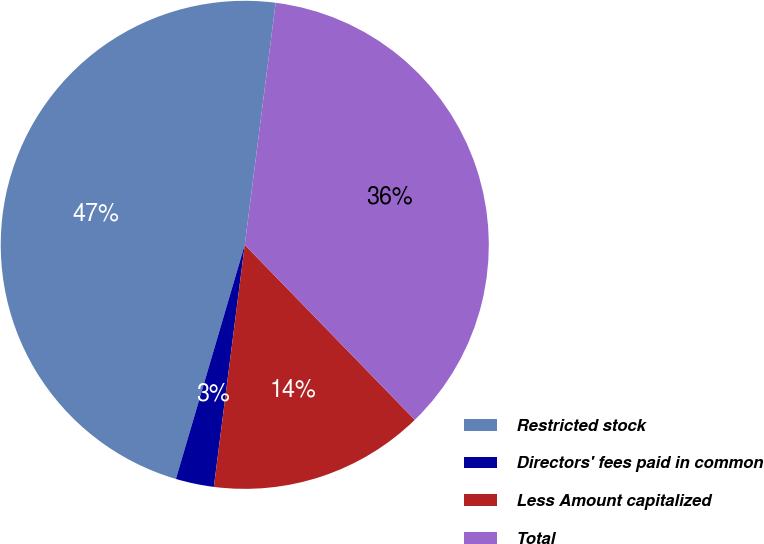<chart> <loc_0><loc_0><loc_500><loc_500><pie_chart><fcel>Restricted stock<fcel>Directors' fees paid in common<fcel>Less Amount capitalized<fcel>Total<nl><fcel>47.47%<fcel>2.53%<fcel>14.29%<fcel>35.71%<nl></chart> 